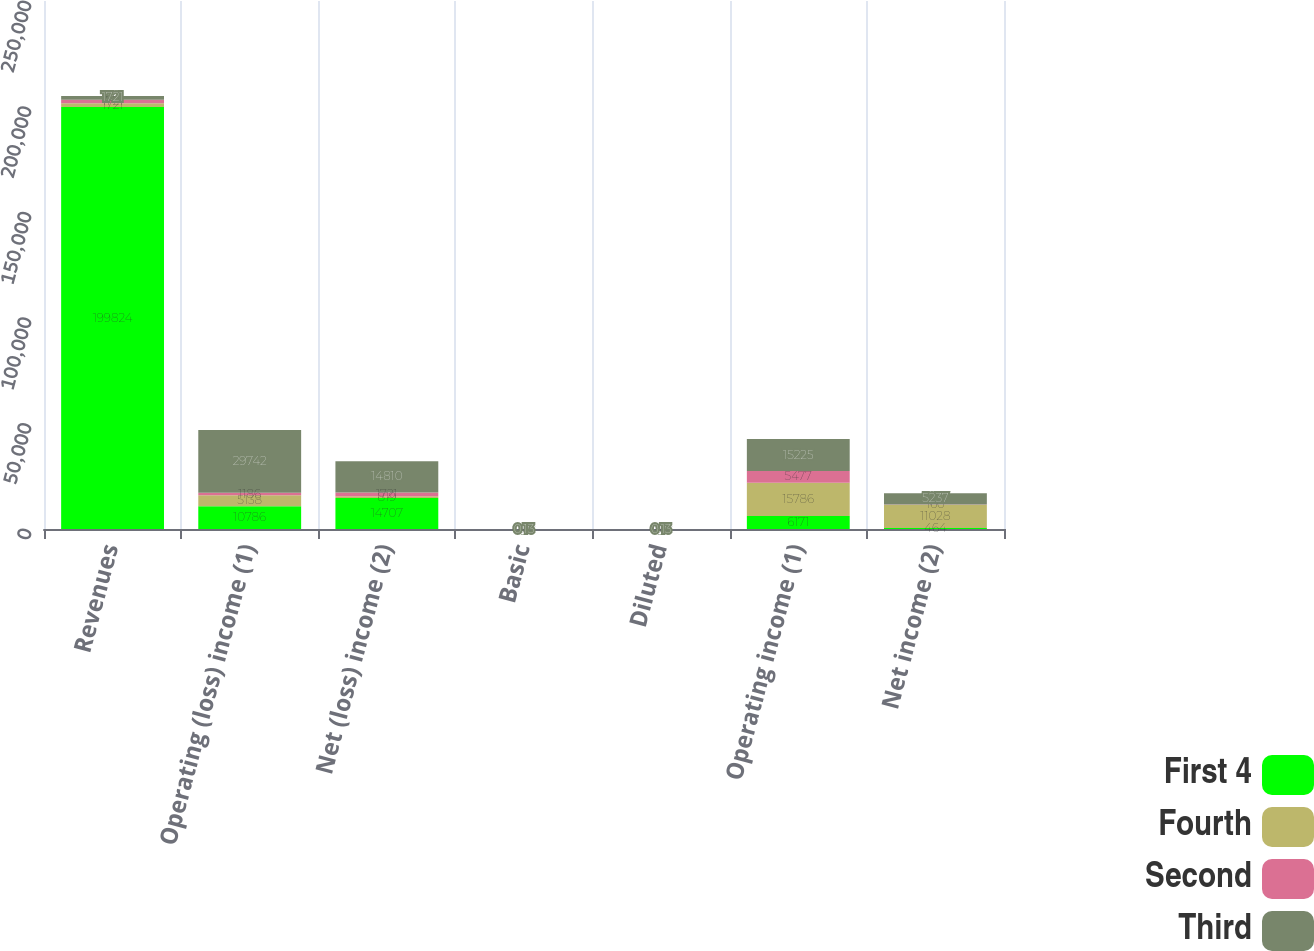Convert chart to OTSL. <chart><loc_0><loc_0><loc_500><loc_500><stacked_bar_chart><ecel><fcel>Revenues<fcel>Operating (loss) income (1)<fcel>Net (loss) income (2)<fcel>Basic<fcel>Diluted<fcel>Operating income (1)<fcel>Net income (2)<nl><fcel>First 4<fcel>199824<fcel>10786<fcel>14707<fcel>0.13<fcel>0.13<fcel>6171<fcel>464<nl><fcel>Fourth<fcel>1721<fcel>5138<fcel>819<fcel>0.01<fcel>0.01<fcel>15786<fcel>11028<nl><fcel>Second<fcel>1721<fcel>1186<fcel>1721<fcel>0.02<fcel>0.02<fcel>5477<fcel>160<nl><fcel>Third<fcel>1721<fcel>29742<fcel>14810<fcel>0.13<fcel>0.13<fcel>15225<fcel>5237<nl></chart> 